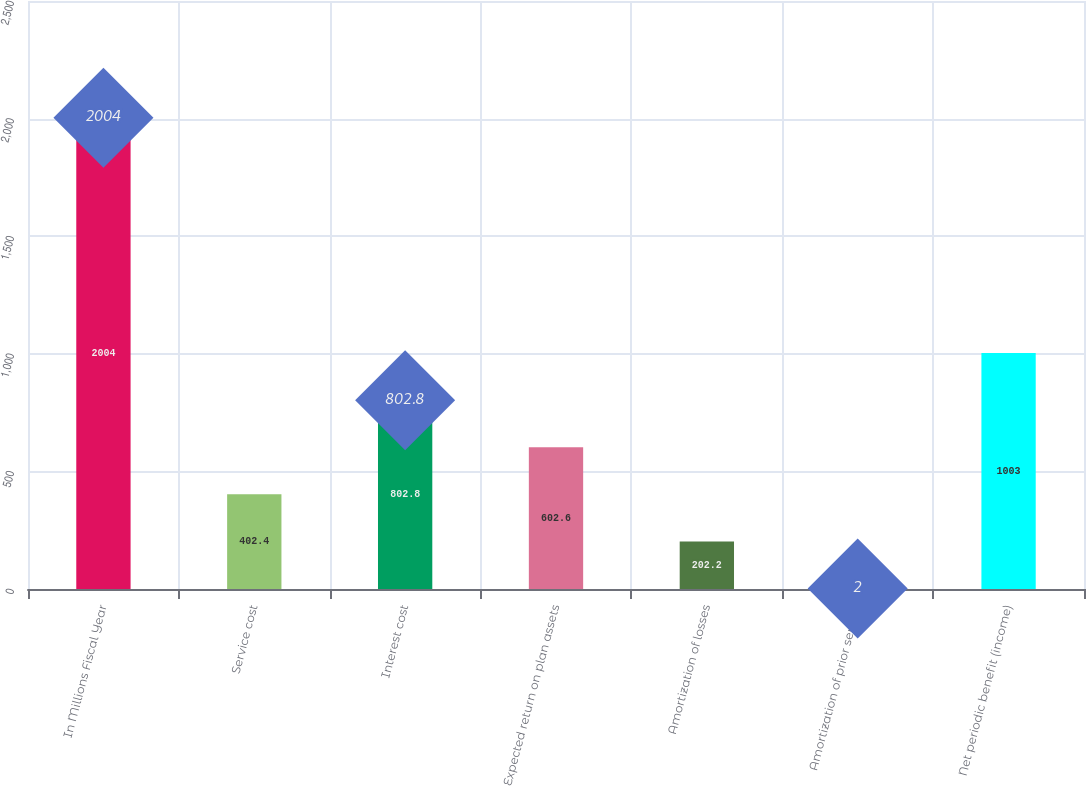Convert chart to OTSL. <chart><loc_0><loc_0><loc_500><loc_500><bar_chart><fcel>In Millions Fiscal Year<fcel>Service cost<fcel>Interest cost<fcel>Expected return on plan assets<fcel>Amortization of losses<fcel>Amortization of prior service<fcel>Net periodic benefit (income)<nl><fcel>2004<fcel>402.4<fcel>802.8<fcel>602.6<fcel>202.2<fcel>2<fcel>1003<nl></chart> 